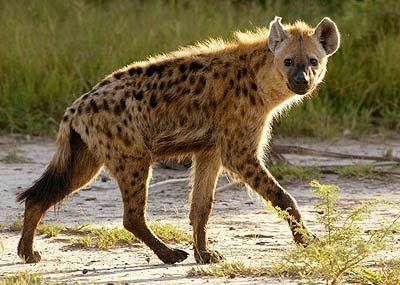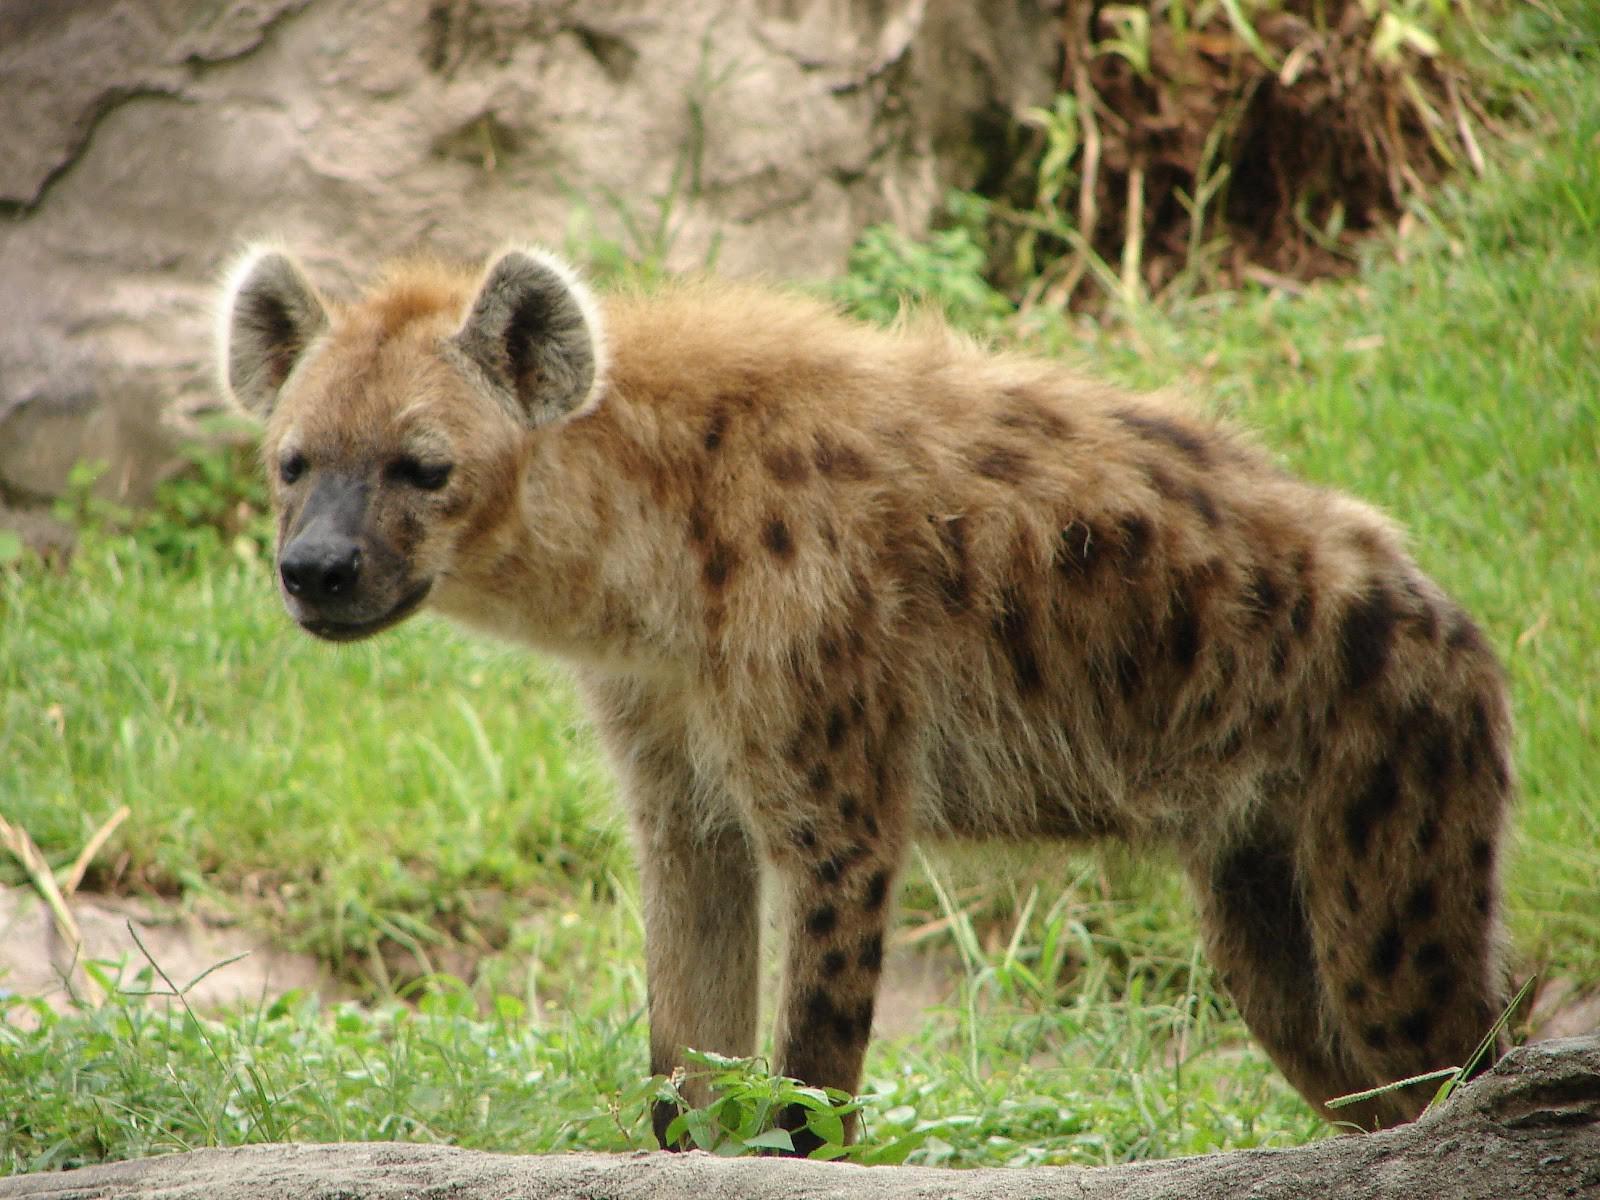The first image is the image on the left, the second image is the image on the right. Analyze the images presented: Is the assertion "A hyena has its mouth wide open" valid? Answer yes or no. No. 